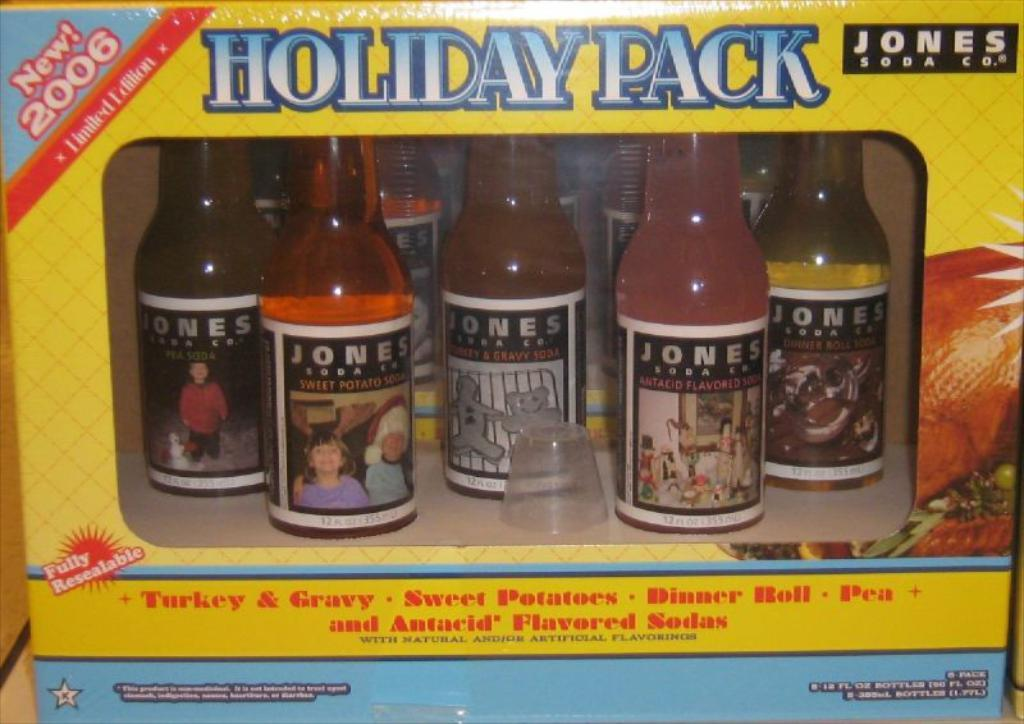What is on the bottles in the image? The bottles have stickers on them. What is inside the bottles? The bottles contain different kinds of drinks. What part of the bottle is visible in the image? A cap is visible in the image. Where are the bottles placed? The bottles are placed in a wooden box. What is on the wooden box? There is a poster on the wooden box. How many pets are sitting on the passenger's lap in the image? There are no pets or passengers present in the image. 